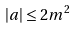<formula> <loc_0><loc_0><loc_500><loc_500>| a | \leq 2 m ^ { 2 }</formula> 